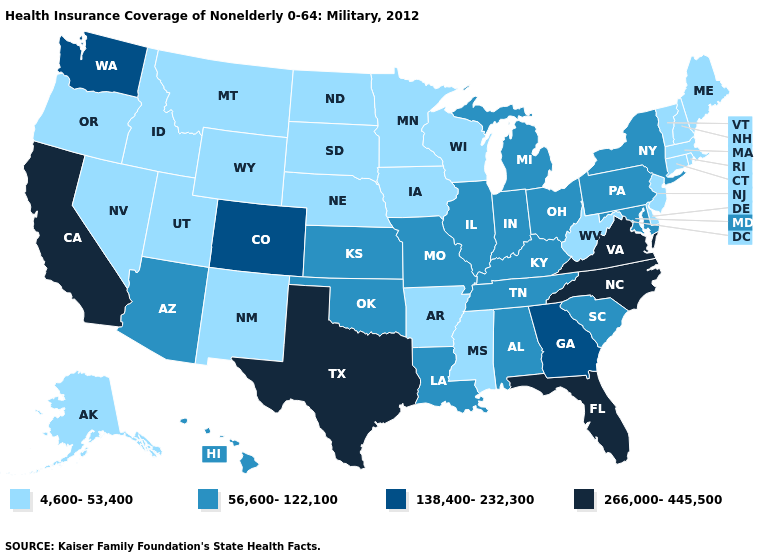What is the value of California?
Be succinct. 266,000-445,500. Name the states that have a value in the range 56,600-122,100?
Be succinct. Alabama, Arizona, Hawaii, Illinois, Indiana, Kansas, Kentucky, Louisiana, Maryland, Michigan, Missouri, New York, Ohio, Oklahoma, Pennsylvania, South Carolina, Tennessee. What is the value of Michigan?
Short answer required. 56,600-122,100. Name the states that have a value in the range 56,600-122,100?
Answer briefly. Alabama, Arizona, Hawaii, Illinois, Indiana, Kansas, Kentucky, Louisiana, Maryland, Michigan, Missouri, New York, Ohio, Oklahoma, Pennsylvania, South Carolina, Tennessee. Is the legend a continuous bar?
Answer briefly. No. Among the states that border Kentucky , does Illinois have the lowest value?
Keep it brief. No. Does Louisiana have the lowest value in the USA?
Short answer required. No. Does Delaware have the lowest value in the South?
Write a very short answer. Yes. What is the value of Florida?
Write a very short answer. 266,000-445,500. What is the highest value in the South ?
Be succinct. 266,000-445,500. Name the states that have a value in the range 56,600-122,100?
Be succinct. Alabama, Arizona, Hawaii, Illinois, Indiana, Kansas, Kentucky, Louisiana, Maryland, Michigan, Missouri, New York, Ohio, Oklahoma, Pennsylvania, South Carolina, Tennessee. Does the map have missing data?
Concise answer only. No. What is the lowest value in the USA?
Answer briefly. 4,600-53,400. Name the states that have a value in the range 138,400-232,300?
Concise answer only. Colorado, Georgia, Washington. Which states have the lowest value in the USA?
Write a very short answer. Alaska, Arkansas, Connecticut, Delaware, Idaho, Iowa, Maine, Massachusetts, Minnesota, Mississippi, Montana, Nebraska, Nevada, New Hampshire, New Jersey, New Mexico, North Dakota, Oregon, Rhode Island, South Dakota, Utah, Vermont, West Virginia, Wisconsin, Wyoming. 